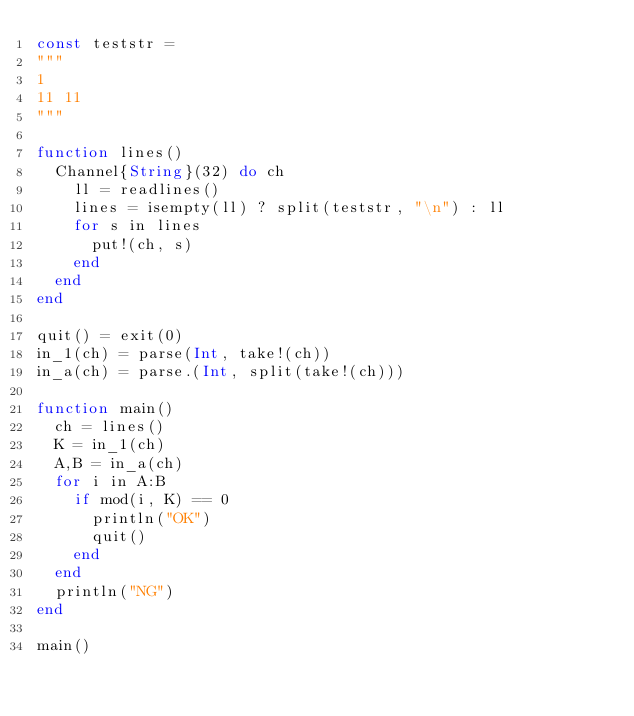Convert code to text. <code><loc_0><loc_0><loc_500><loc_500><_Julia_>const teststr = 
"""
1
11 11
"""

function lines()
  Channel{String}(32) do ch
    ll = readlines()
    lines = isempty(ll) ? split(teststr, "\n") : ll
    for s in lines
      put!(ch, s)
    end
  end
end

quit() = exit(0)
in_1(ch) = parse(Int, take!(ch))
in_a(ch) = parse.(Int, split(take!(ch)))

function main()
  ch = lines()
  K = in_1(ch)
  A,B = in_a(ch)
  for i in A:B
    if mod(i, K) == 0
      println("OK")
      quit()
    end
  end
  println("NG")
end

main()
</code> 